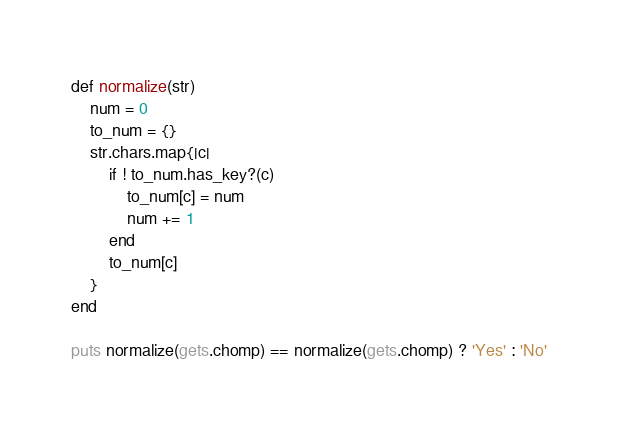Convert code to text. <code><loc_0><loc_0><loc_500><loc_500><_Ruby_>def normalize(str)
    num = 0
    to_num = {}
    str.chars.map{|c|
        if ! to_num.has_key?(c)
            to_num[c] = num
            num += 1
        end
        to_num[c]
    }
end

puts normalize(gets.chomp) == normalize(gets.chomp) ? 'Yes' : 'No'
</code> 